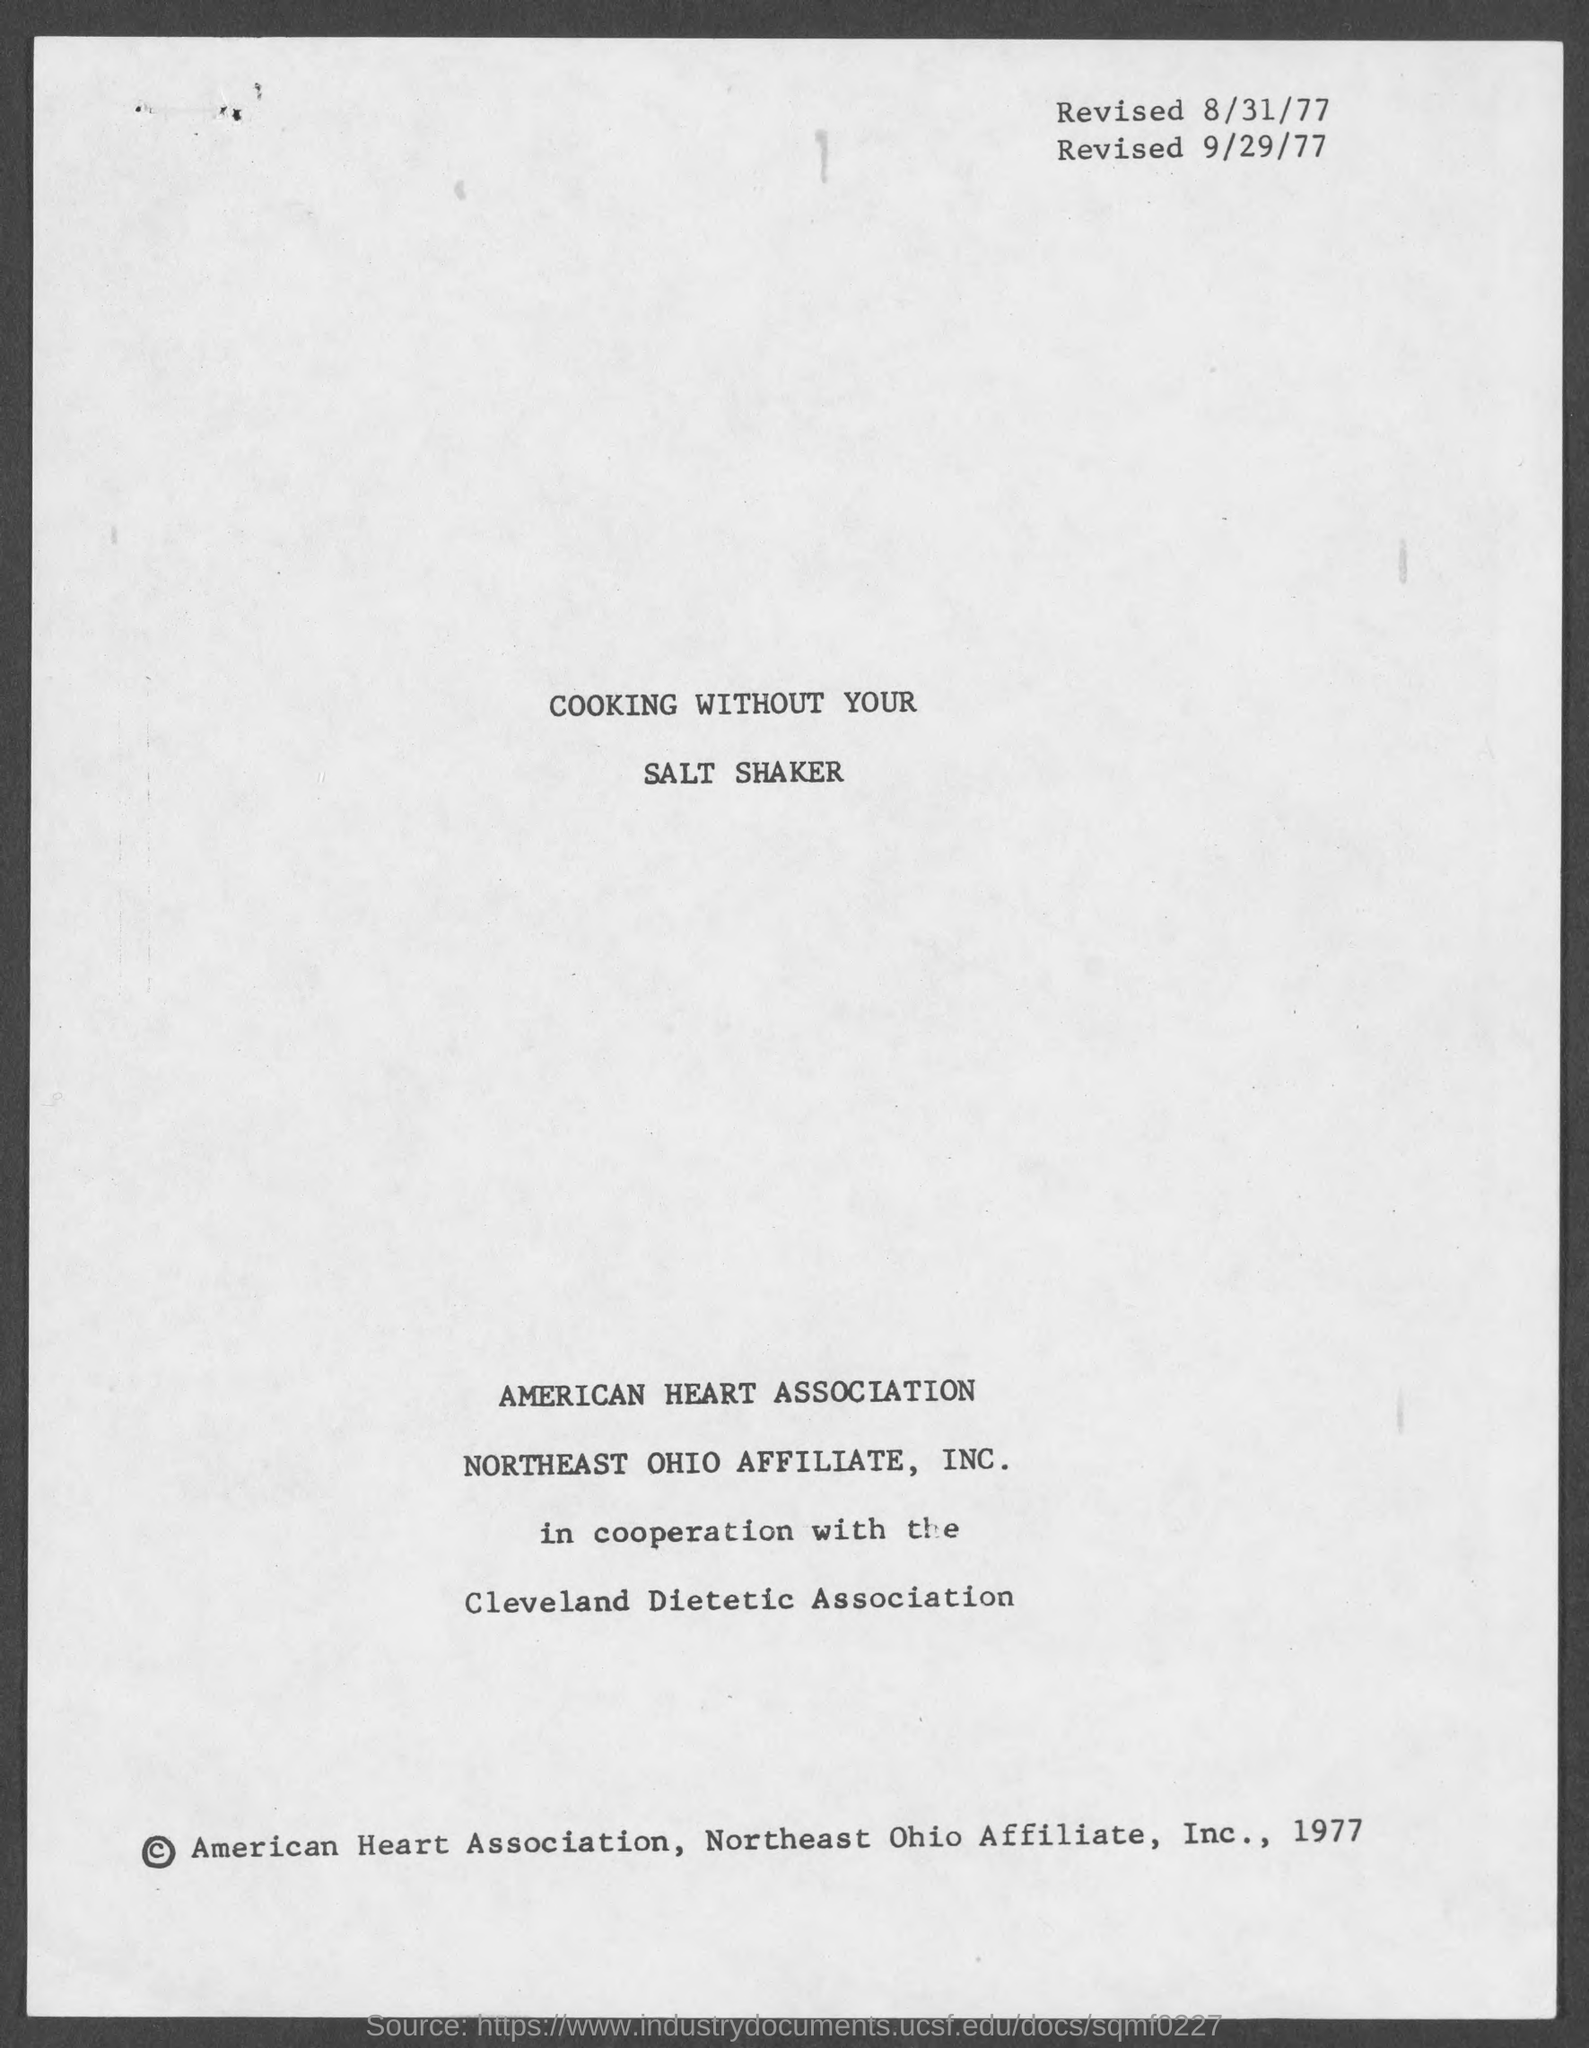What is the first revised date?
Offer a terse response. 8/31/77. What is the second revised date?
Keep it short and to the point. 9/29/77. What is the title of the document?
Make the answer very short. Cooking without your salt shaker. 